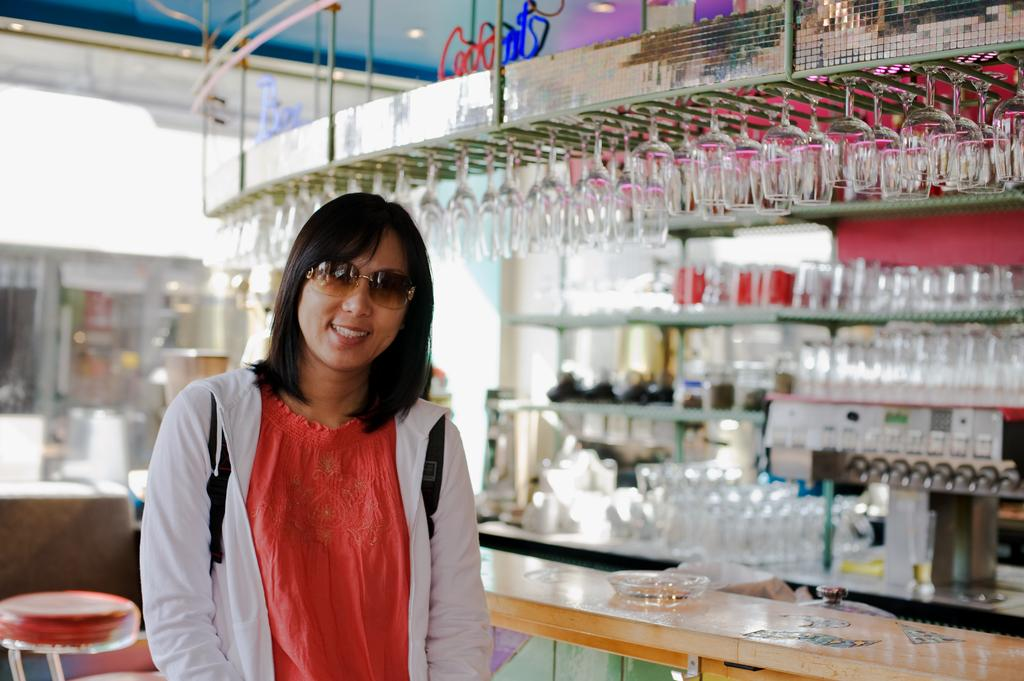Who is the main subject in the image? There is a woman in the image. What is the woman wearing on her face? The woman is wearing spectacles. What is the woman's facial expression in the image? The woman is smiling. What objects can be seen in the image besides the woman? There are glasses visible in the image. How would you describe the background of the image? The background of the image is blurry. How many babies are being carried by the woman in the image? There are no babies present in the image; it features a woman wearing spectacles and smiling. What type of grandmother is depicted in the image? There is no grandmother depicted in the image; it features a woman wearing spectacles and smiling. 